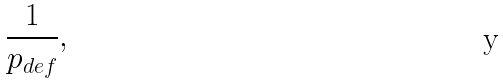<formula> <loc_0><loc_0><loc_500><loc_500>\frac { 1 } { p _ { d e f } } ,</formula> 